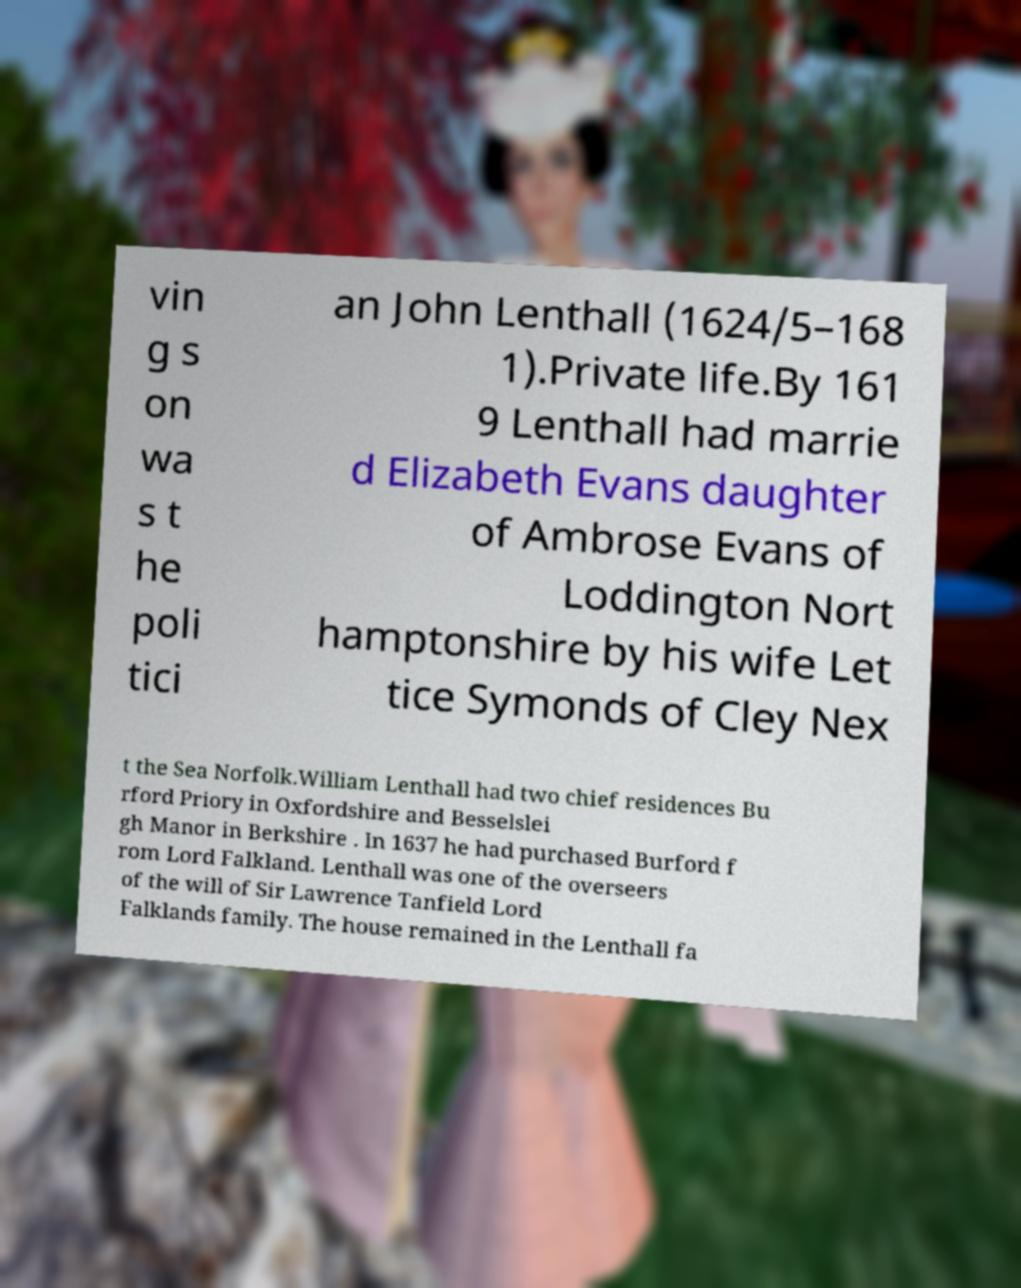I need the written content from this picture converted into text. Can you do that? vin g s on wa s t he poli tici an John Lenthall (1624/5–168 1).Private life.By 161 9 Lenthall had marrie d Elizabeth Evans daughter of Ambrose Evans of Loddington Nort hamptonshire by his wife Let tice Symonds of Cley Nex t the Sea Norfolk.William Lenthall had two chief residences Bu rford Priory in Oxfordshire and Besselslei gh Manor in Berkshire . In 1637 he had purchased Burford f rom Lord Falkland. Lenthall was one of the overseers of the will of Sir Lawrence Tanfield Lord Falklands family. The house remained in the Lenthall fa 